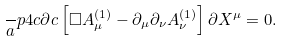<formula> <loc_0><loc_0><loc_500><loc_500>\frac { \ } { a } p 4 c \partial c \left [ \Box A _ { \mu } ^ { ( 1 ) } - \partial _ { \mu } \partial _ { \nu } A _ { \nu } ^ { ( 1 ) } \right ] \partial X ^ { \mu } = 0 .</formula> 